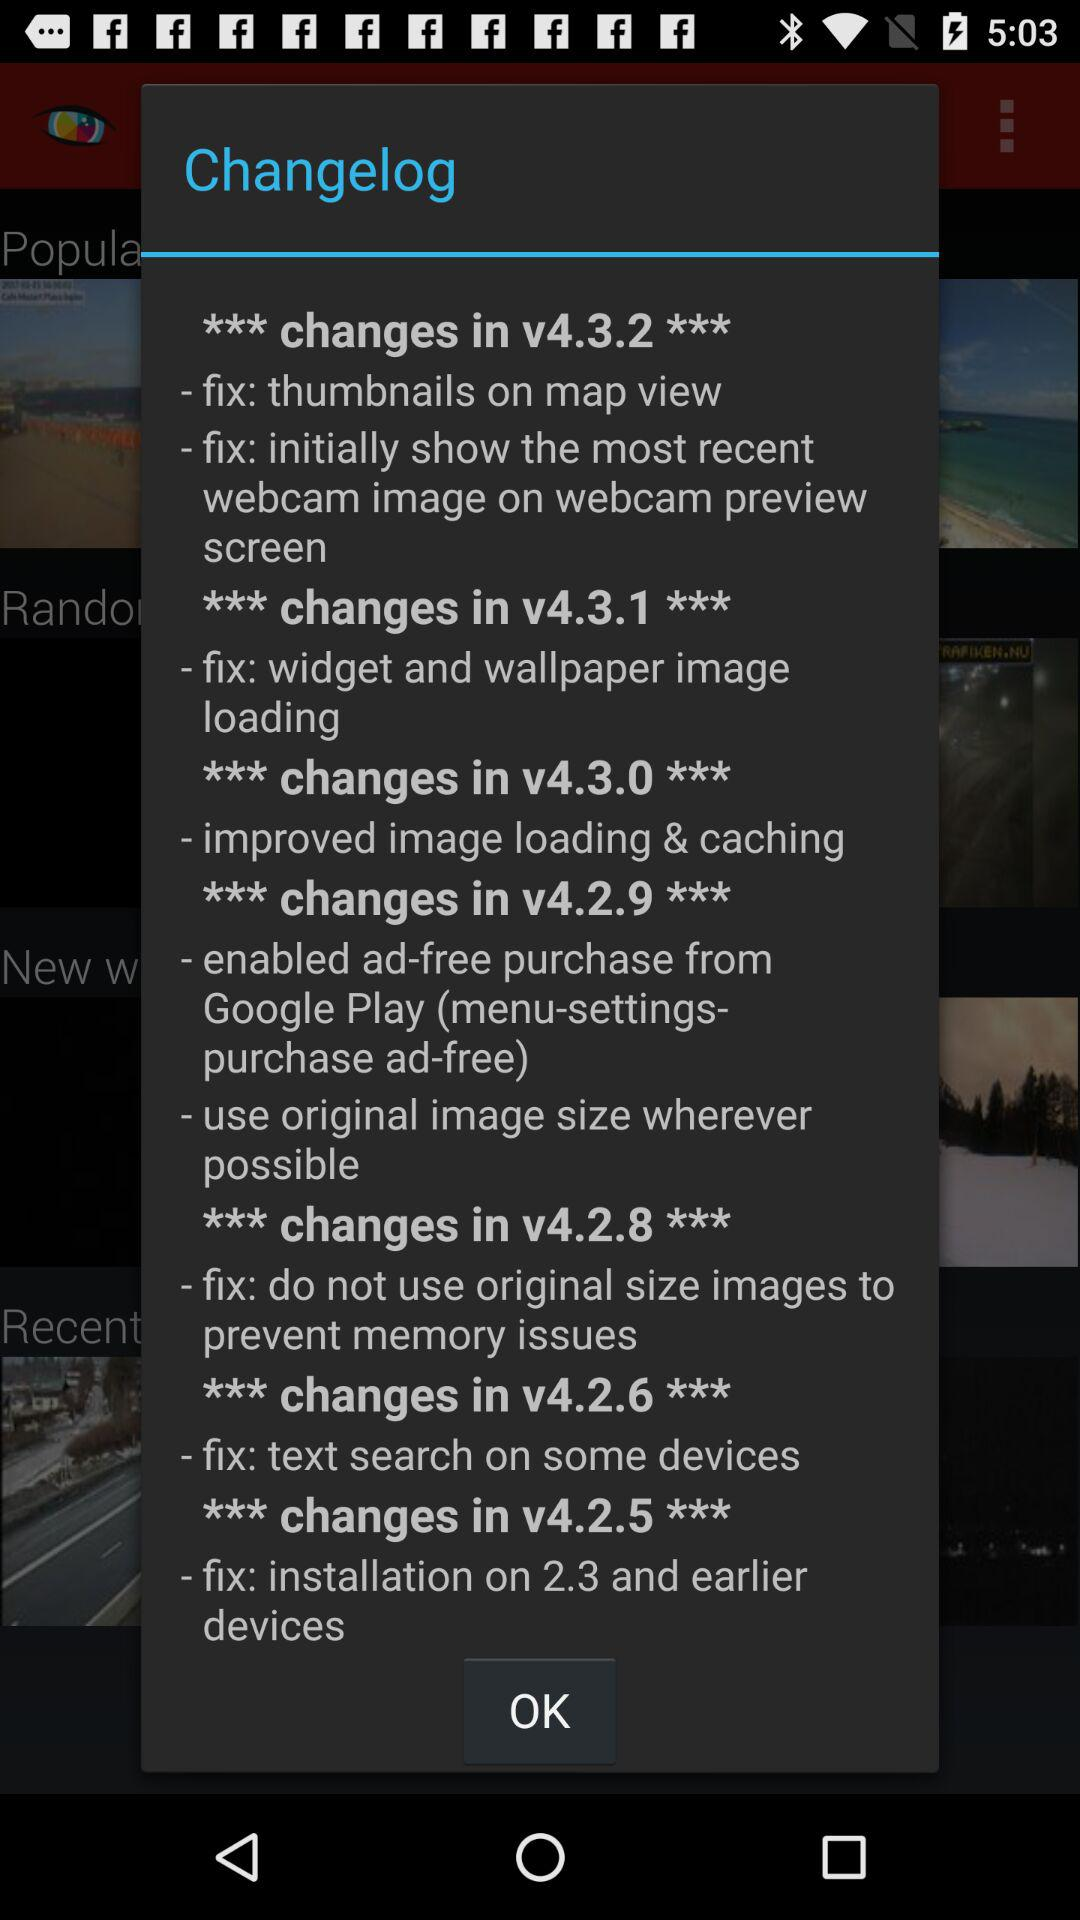What are the updates in version 4.2.5? The update in version 4.2.5 is "fix: installation on 2.3 and earlier devices". 